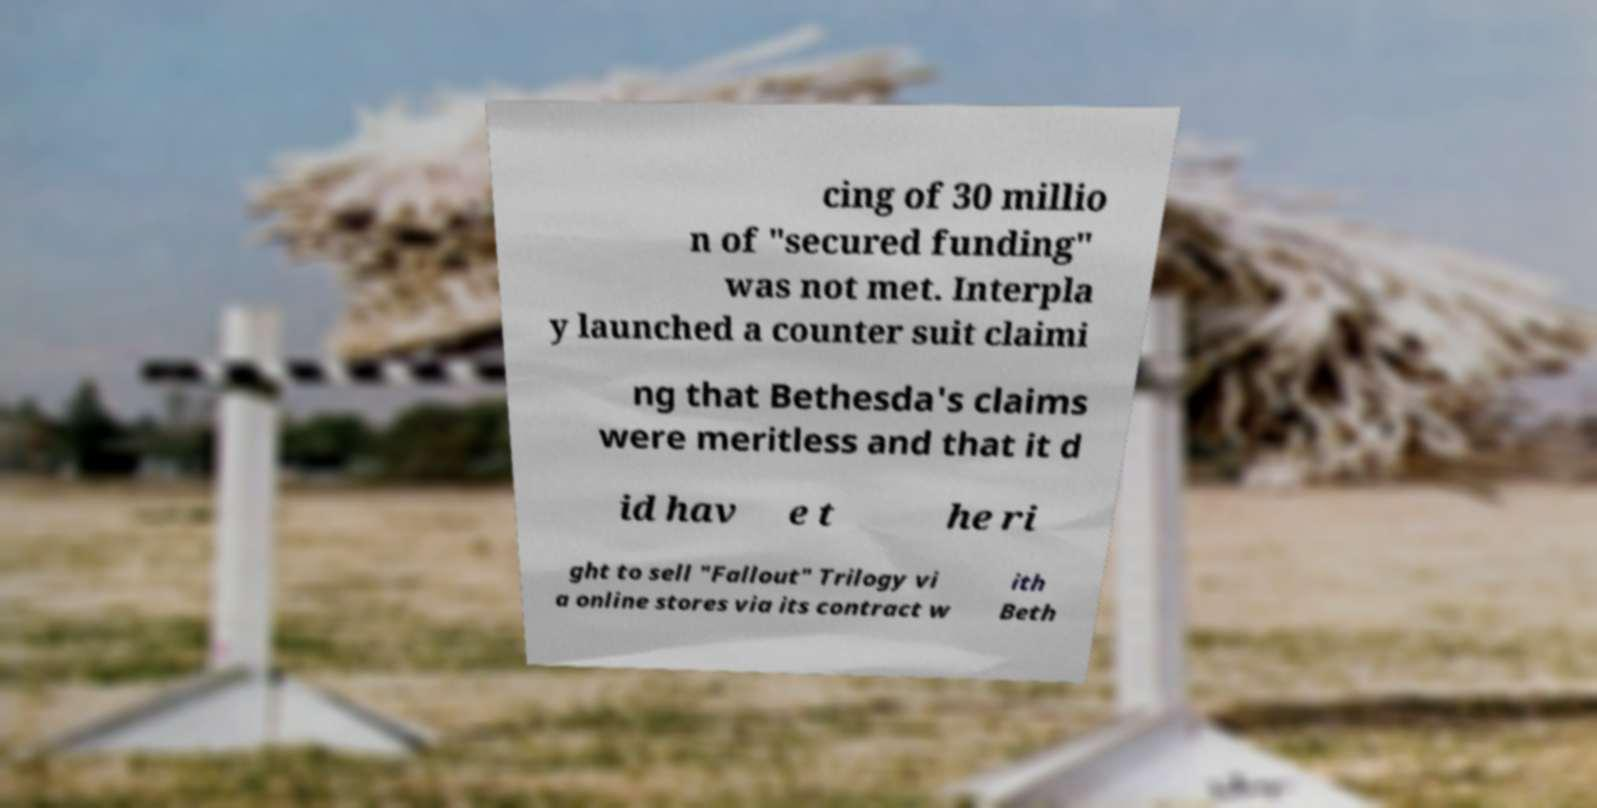Could you extract and type out the text from this image? cing of 30 millio n of "secured funding" was not met. Interpla y launched a counter suit claimi ng that Bethesda's claims were meritless and that it d id hav e t he ri ght to sell "Fallout" Trilogy vi a online stores via its contract w ith Beth 